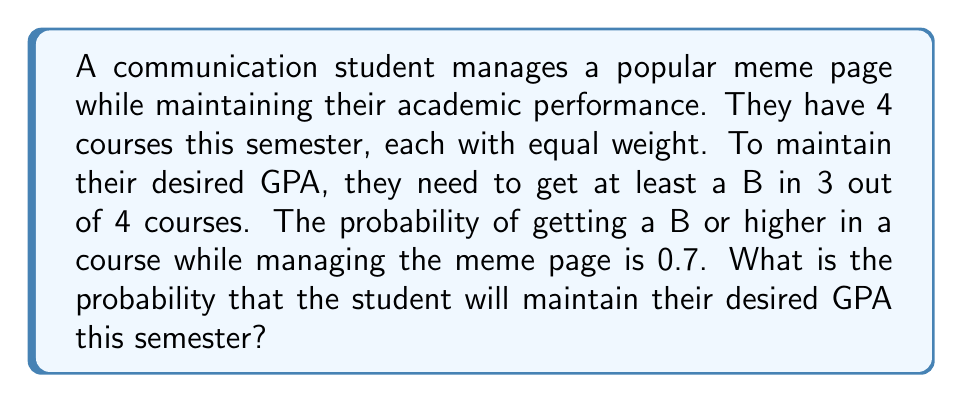Can you answer this question? Let's approach this step-by-step:

1) This scenario follows a binomial probability distribution. We need to calculate the probability of getting at least 3 successes (B or higher) out of 4 trials (courses).

2) The probability of success (getting a B or higher) in each course is 0.7.

3) We need to calculate P(X ≥ 3), where X is the number of courses with a B or higher.

4) This can be calculated as: P(X = 3) + P(X = 4)

5) The binomial probability formula is:

   $$P(X = k) = \binom{n}{k} p^k (1-p)^{n-k}$$

   where n is the number of trials, k is the number of successes, p is the probability of success.

6) For P(X = 3):
   $$P(X = 3) = \binom{4}{3} (0.7)^3 (0.3)^1 = 4 * 0.343 * 0.3 = 0.4116$$

7) For P(X = 4):
   $$P(X = 4) = \binom{4}{4} (0.7)^4 (0.3)^0 = 1 * 0.2401 * 1 = 0.2401$$

8) Therefore, P(X ≥ 3) = P(X = 3) + P(X = 4) = 0.4116 + 0.2401 = 0.6517
Answer: 0.6517 